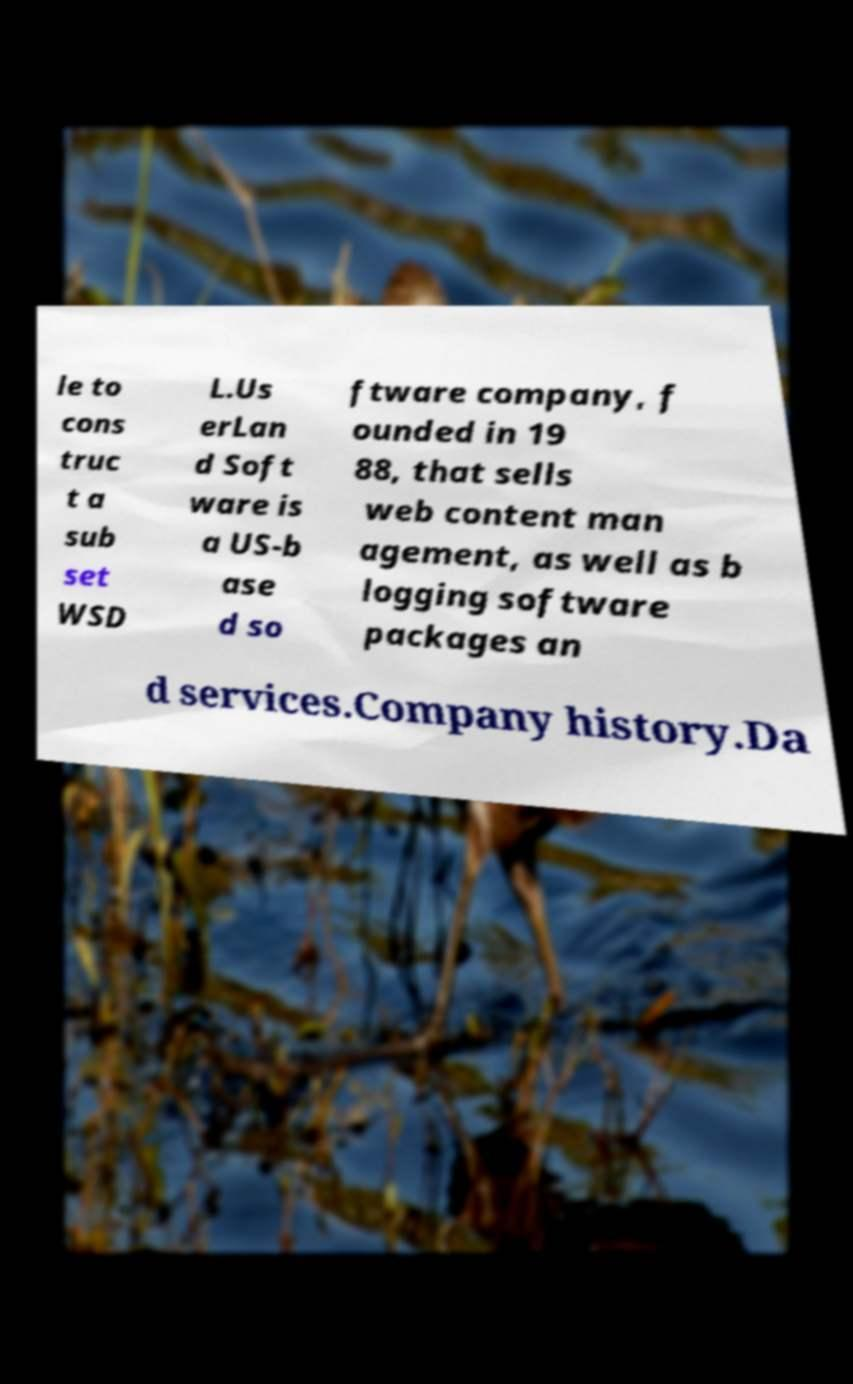Can you accurately transcribe the text from the provided image for me? le to cons truc t a sub set WSD L.Us erLan d Soft ware is a US-b ase d so ftware company, f ounded in 19 88, that sells web content man agement, as well as b logging software packages an d services.Company history.Da 